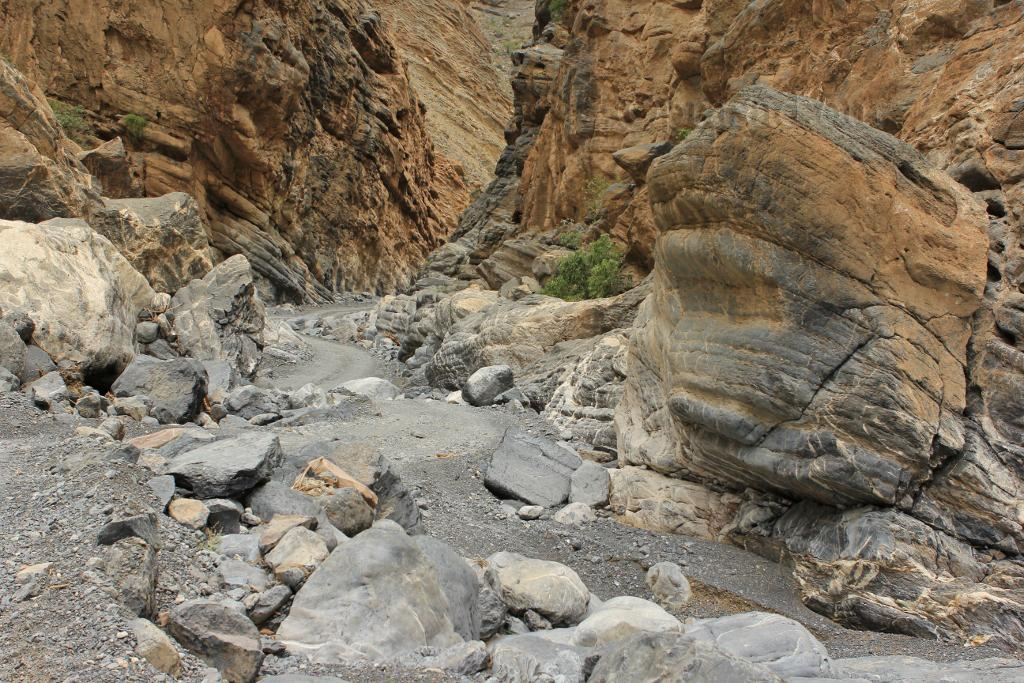What type of natural elements can be seen in the image? There are stones and plants visible in the image. What other geological features can be seen in the image? There are rocks in the image. Where is the hall located in the image? There is no hall present in the image. What type of clothing item is visible in the image? There are no clothing items visible in the image. What time of day is depicted in the image? The time of day is not discernible from the image. 